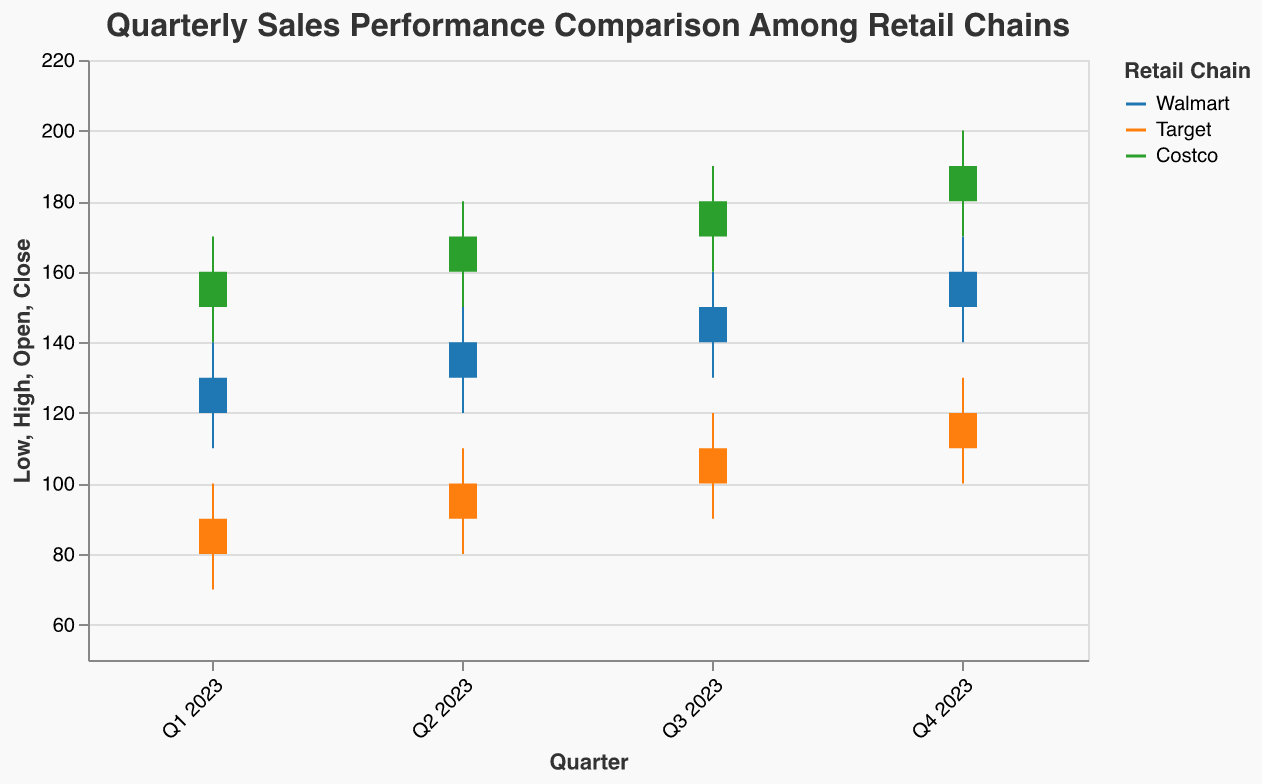What's the title of the figure? The title is located at the top of the figure and provides the main context.
Answer: Quarterly Sales Performance Comparison Among Retail Chains How many retail chains are compared in the figure? The legend indicates the number of distinct retail chains compared by different colors.
Answer: Three Which retail chain had the highest sales in Q4 2023? Compare the "High" values for each retail chain in Q4 2023. Costco has the highest value of 200.
Answer: Costco What are the color codes used for each retail chain? Check the legend to see the colors associated with each retail chain.
Answer: Walmart: blue, Target: orange, Costco: green Did Walmart’s sales increase or decrease from Q2 2023 to Q3 2023? Compare the "Close" value of Q2 (140) to the "Close" value of Q3 (150). Since 150 is greater than 140, Walmart’s sales increased.
Answer: Increase What is the difference between Target's highest and lowest sales in Q3 2023? Subtract the "Low" value from the "High" value for Target in Q3 2023 (120 - 90).
Answer: 30 Which quarter had the highest opening sales for Costco? Compare the "Open" values for each quarter for Costco and select the highest one. Q4 2023 has the highest opening sales of 180.
Answer: Q4 2023 On average, how much did Walmart’s sales rise from Q1 to Q4 2023? Calculate the average increase from Q1 to Q2, Q2 to Q3, and Q3 to Q4. The increases are 10 (130-120), 10 (140-130), and 10 (150-140). Therefore, the average increase is 10.
Answer: 10 Compare the Q1 2023 closing sales between Walmart and Target. Who had higher closing sales? Look at the "Close" values for Walmart and Target in Q1 2023. Walmart has 130, and Target has 90. Therefore, Walmart had higher closing sales.
Answer: Walmart From the given data, did Costco ever have sales that dropped below Walmart's sales in any quarter of 2023? Check the "Low" values for Costco and compare them with those of Walmart for each quarter. Costco's lowest value is 140, which is higher than Walmart's highest "Low" value of 140 in Q4.
Answer: No 